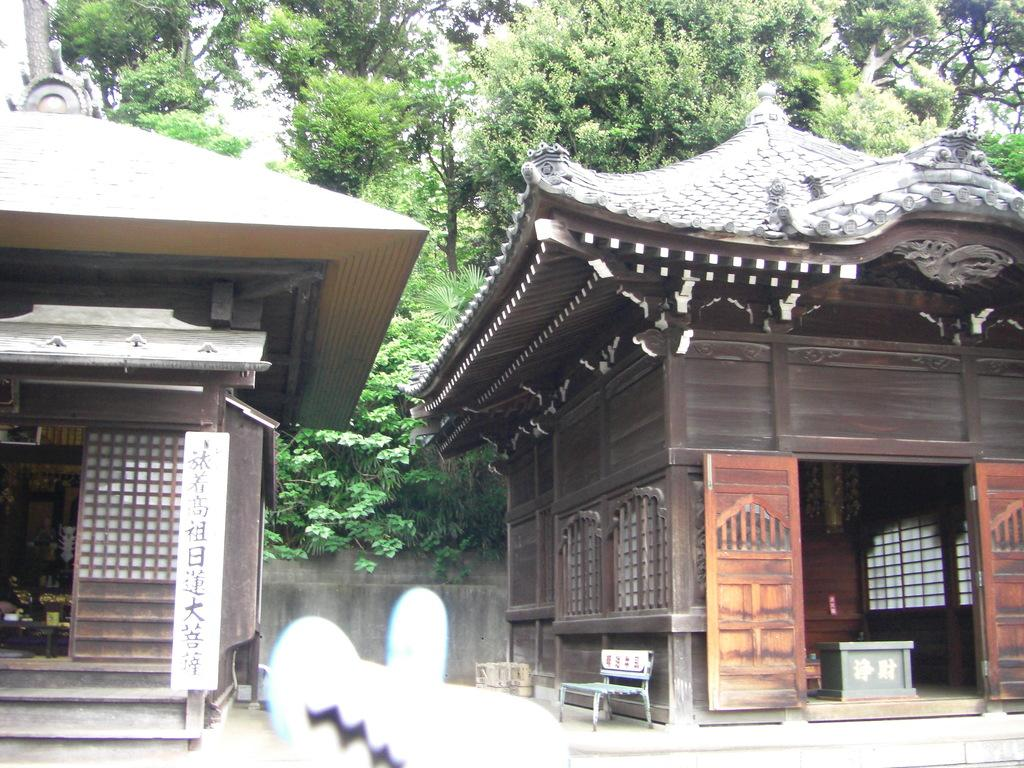What are the main structures in the center of the image? There are two houses in the center of the image. What can be seen in the background of the image? There are trees in the background of the image. What color is the bag hanging from the tree in the image? There is no bag hanging from a tree in the image; it only features two houses and trees in the background. 